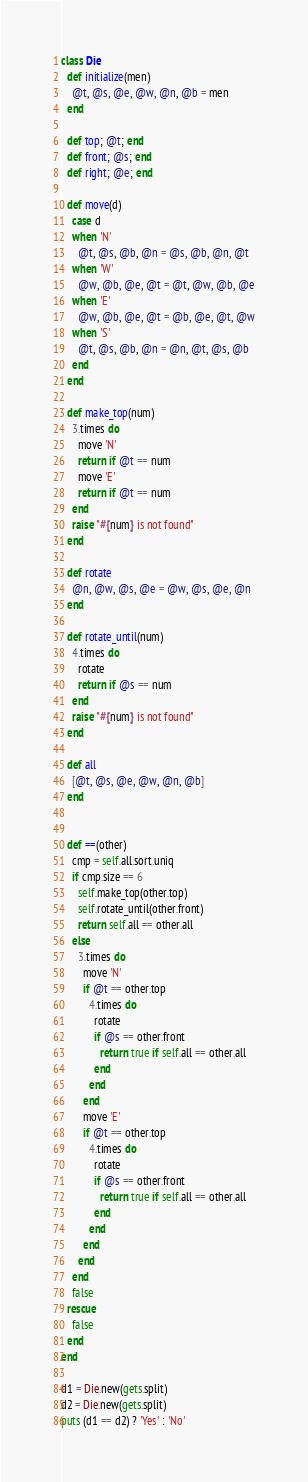Convert code to text. <code><loc_0><loc_0><loc_500><loc_500><_Ruby_>class Die
  def initialize(men)
    @t, @s, @e, @w, @n, @b = men
  end

  def top; @t; end
  def front; @s; end
  def right; @e; end

  def move(d)
    case d
    when 'N'
      @t, @s, @b, @n = @s, @b, @n, @t
    when 'W'
      @w, @b, @e, @t = @t, @w, @b, @e
    when 'E'
      @w, @b, @e, @t = @b, @e, @t, @w
    when 'S'
      @t, @s, @b, @n = @n, @t, @s, @b
    end
  end

  def make_top(num)
    3.times do
      move 'N'
      return if @t == num
      move 'E'
      return if @t == num
    end
    raise "#{num} is not found"
  end

  def rotate
    @n, @w, @s, @e = @w, @s, @e, @n
  end

  def rotate_until(num)
    4.times do
      rotate
      return if @s == num
    end
    raise "#{num} is not found"
  end

  def all
    [@t, @s, @e, @w, @n, @b]
  end


  def ==(other)
    cmp = self.all.sort.uniq
    if cmp.size == 6
      self.make_top(other.top)
      self.rotate_until(other.front)
      return self.all == other.all
    else
      3.times do
        move 'N'
        if @t == other.top
          4.times do
            rotate
            if @s == other.front
              return true if self.all == other.all
            end
          end
        end
        move 'E'
        if @t == other.top
          4.times do
            rotate
            if @s == other.front
              return true if self.all == other.all
            end
          end
        end
      end
    end
    false
  rescue
    false
  end
end

d1 = Die.new(gets.split)
d2 = Die.new(gets.split)
puts (d1 == d2) ? 'Yes' : 'No'

</code> 